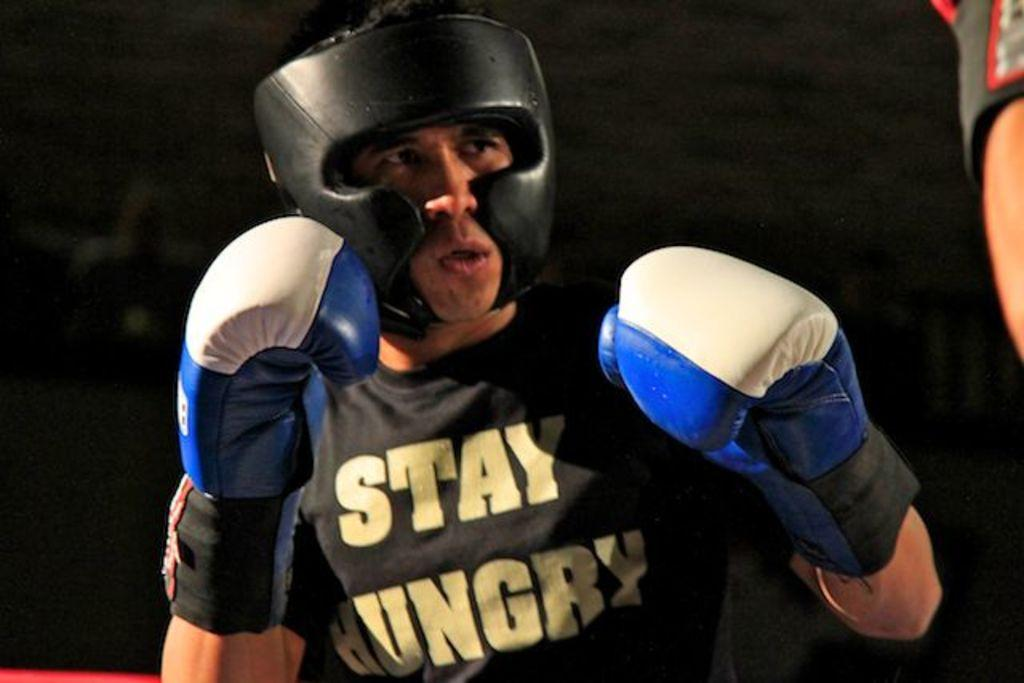Who or what is the main subject in the center of the image? There is a person in the center of the image. What protective gear is the person wearing? The person is wearing a helmet and gloves. Can you describe anything else on the right side of the image? There is a human hand on the right side of the image. What type of rabbit can be seen digging a hole in the image? There is no rabbit or hole present in the image; it features a person wearing a helmet and gloves. 